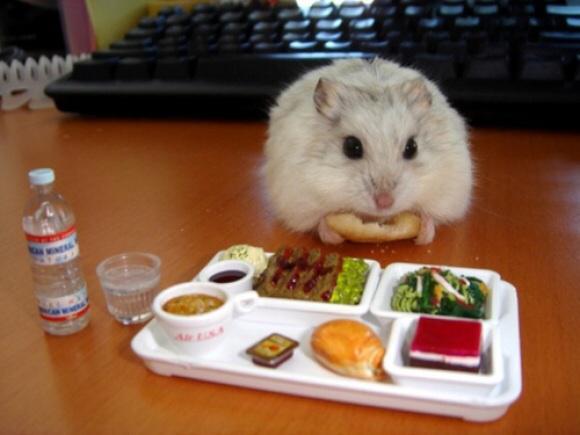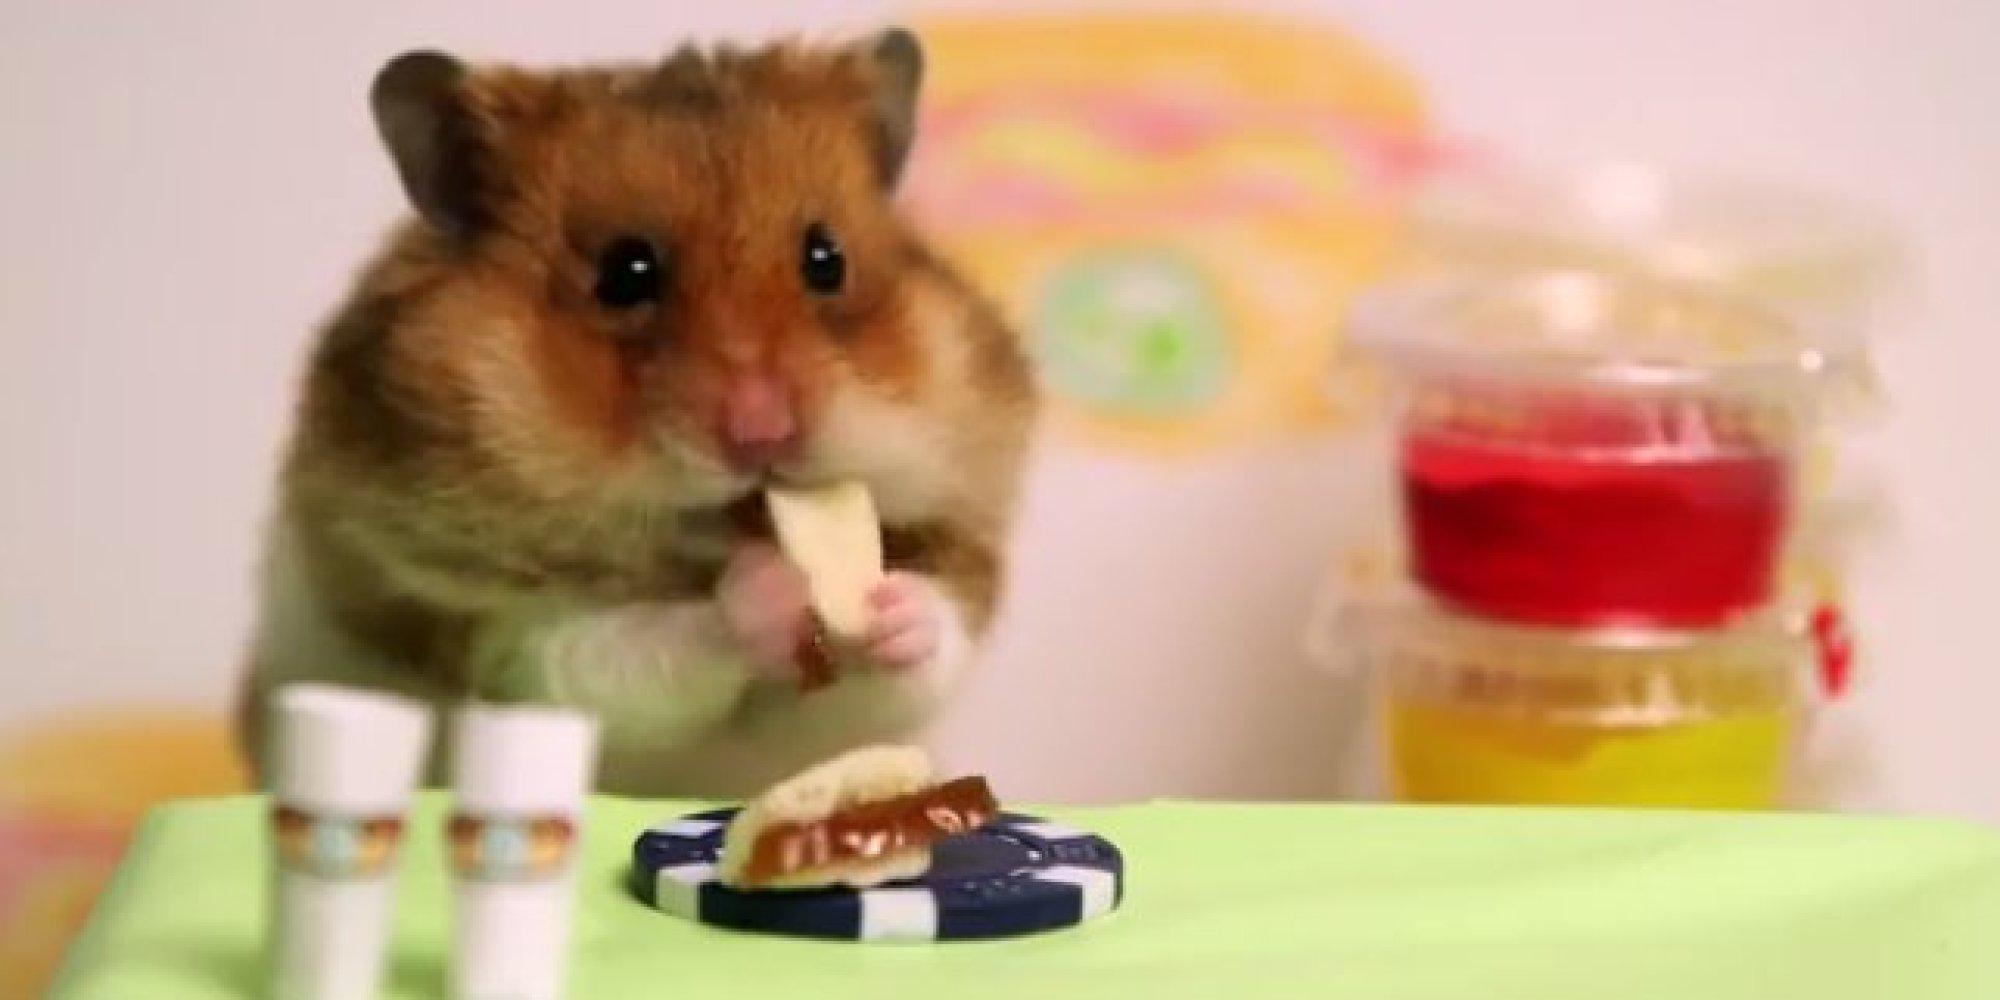The first image is the image on the left, the second image is the image on the right. Considering the images on both sides, is "The surface in one of the images is not covered by a table cloth." valid? Answer yes or no. Yes. The first image is the image on the left, the second image is the image on the right. Considering the images on both sides, is "An image shows a hamster eating at a green """"table"""" that holds a poker chip """"dish"""" with white notch marks around its edge." valid? Answer yes or no. Yes. 